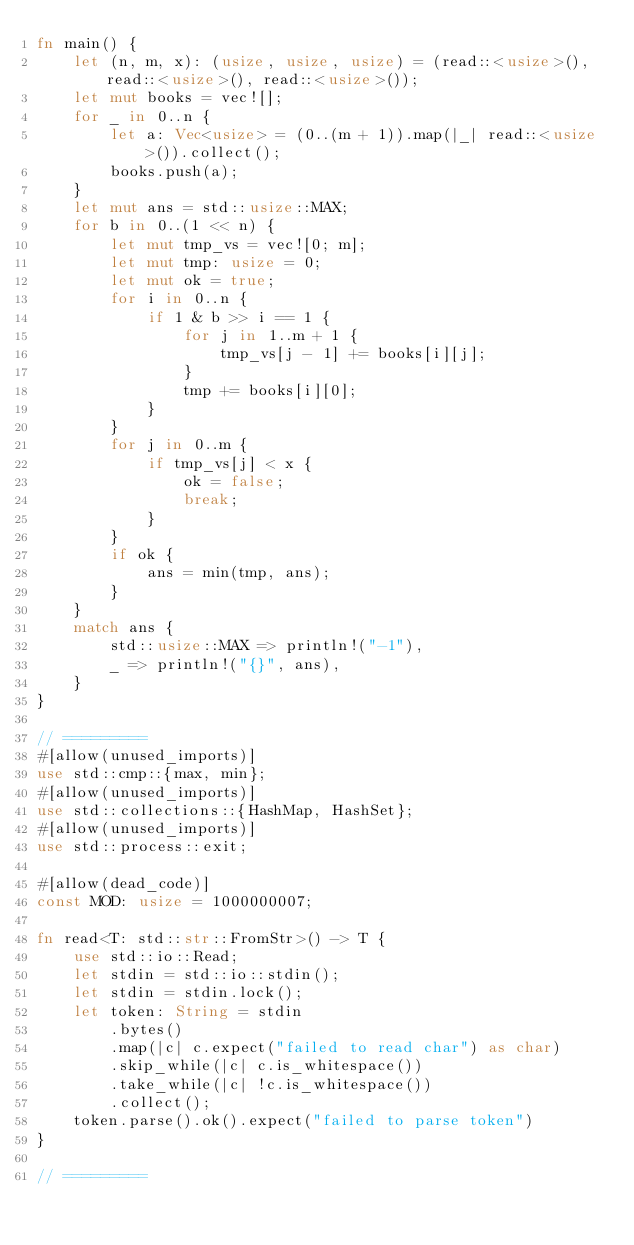Convert code to text. <code><loc_0><loc_0><loc_500><loc_500><_Rust_>fn main() {
    let (n, m, x): (usize, usize, usize) = (read::<usize>(), read::<usize>(), read::<usize>());
    let mut books = vec![];
    for _ in 0..n {
        let a: Vec<usize> = (0..(m + 1)).map(|_| read::<usize>()).collect();
        books.push(a);
    }
    let mut ans = std::usize::MAX;
    for b in 0..(1 << n) {
        let mut tmp_vs = vec![0; m];
        let mut tmp: usize = 0;
        let mut ok = true;
        for i in 0..n {
            if 1 & b >> i == 1 {
                for j in 1..m + 1 {
                    tmp_vs[j - 1] += books[i][j];
                }
                tmp += books[i][0];
            }
        }
        for j in 0..m {
            if tmp_vs[j] < x {
                ok = false;
                break;
            }
        }
        if ok {
            ans = min(tmp, ans);
        }
    }
    match ans {
        std::usize::MAX => println!("-1"),
        _ => println!("{}", ans),
    }
}

// =========
#[allow(unused_imports)]
use std::cmp::{max, min};
#[allow(unused_imports)]
use std::collections::{HashMap, HashSet};
#[allow(unused_imports)]
use std::process::exit;

#[allow(dead_code)]
const MOD: usize = 1000000007;

fn read<T: std::str::FromStr>() -> T {
    use std::io::Read;
    let stdin = std::io::stdin();
    let stdin = stdin.lock();
    let token: String = stdin
        .bytes()
        .map(|c| c.expect("failed to read char") as char)
        .skip_while(|c| c.is_whitespace())
        .take_while(|c| !c.is_whitespace())
        .collect();
    token.parse().ok().expect("failed to parse token")
}

// =========
</code> 